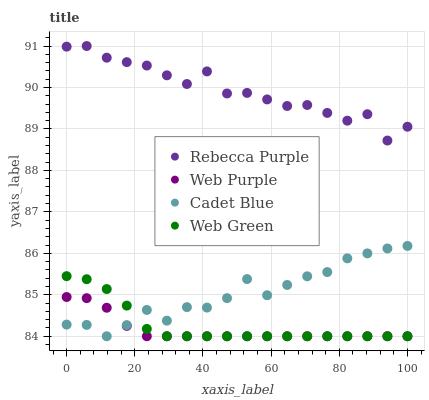Does Web Purple have the minimum area under the curve?
Answer yes or no. Yes. Does Rebecca Purple have the maximum area under the curve?
Answer yes or no. Yes. Does Cadet Blue have the minimum area under the curve?
Answer yes or no. No. Does Cadet Blue have the maximum area under the curve?
Answer yes or no. No. Is Web Purple the smoothest?
Answer yes or no. Yes. Is Rebecca Purple the roughest?
Answer yes or no. Yes. Is Cadet Blue the smoothest?
Answer yes or no. No. Is Cadet Blue the roughest?
Answer yes or no. No. Does Web Purple have the lowest value?
Answer yes or no. Yes. Does Rebecca Purple have the lowest value?
Answer yes or no. No. Does Rebecca Purple have the highest value?
Answer yes or no. Yes. Does Cadet Blue have the highest value?
Answer yes or no. No. Is Web Purple less than Rebecca Purple?
Answer yes or no. Yes. Is Rebecca Purple greater than Cadet Blue?
Answer yes or no. Yes. Does Web Green intersect Cadet Blue?
Answer yes or no. Yes. Is Web Green less than Cadet Blue?
Answer yes or no. No. Is Web Green greater than Cadet Blue?
Answer yes or no. No. Does Web Purple intersect Rebecca Purple?
Answer yes or no. No. 